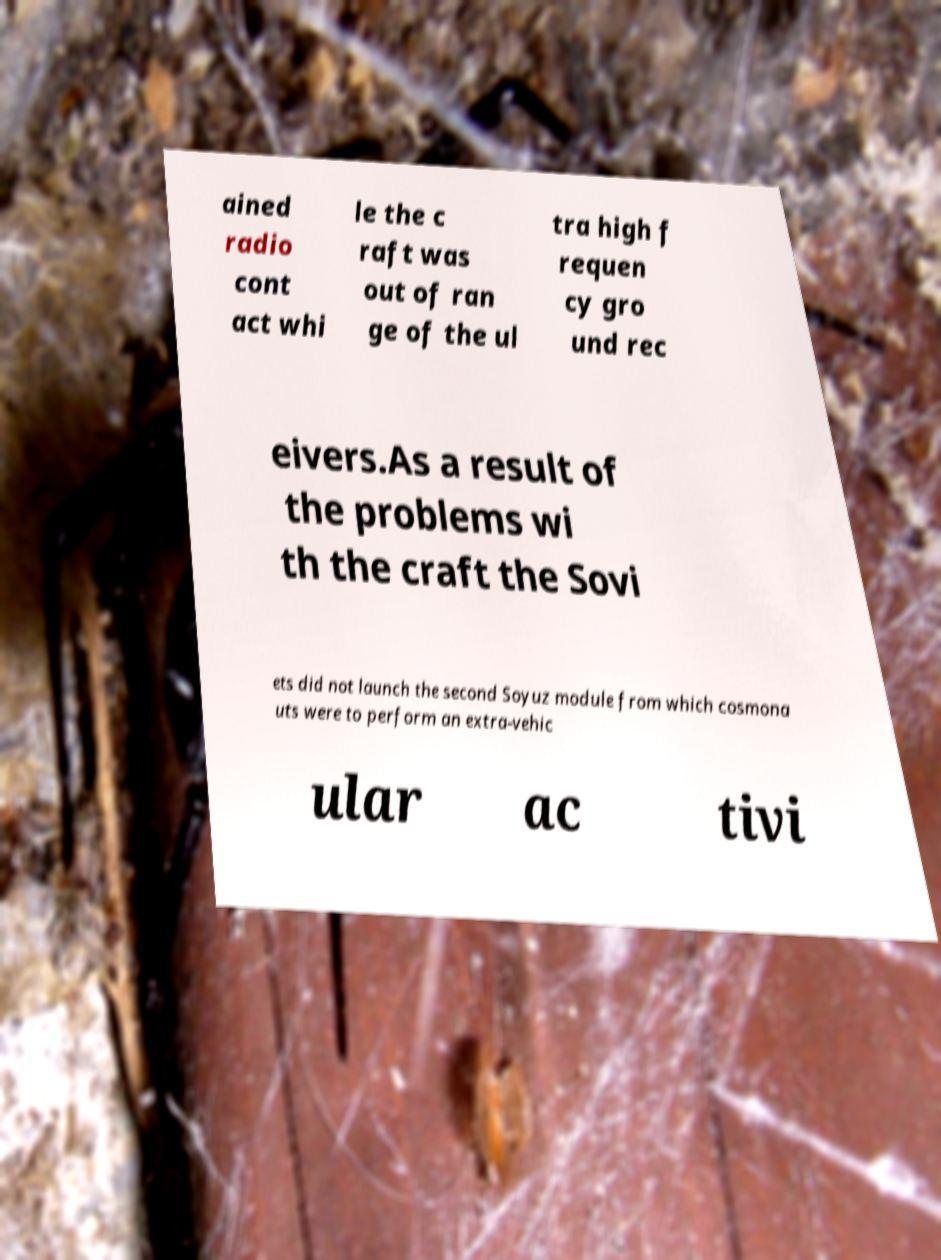Can you accurately transcribe the text from the provided image for me? ained radio cont act whi le the c raft was out of ran ge of the ul tra high f requen cy gro und rec eivers.As a result of the problems wi th the craft the Sovi ets did not launch the second Soyuz module from which cosmona uts were to perform an extra-vehic ular ac tivi 